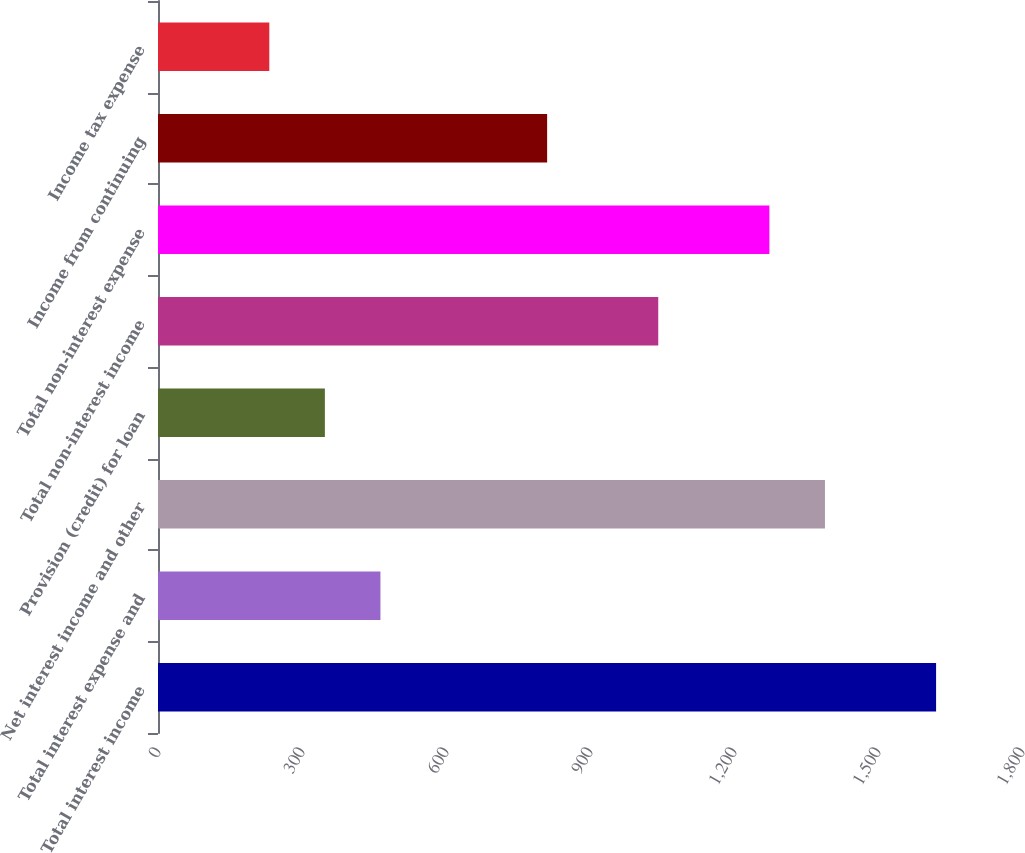Convert chart. <chart><loc_0><loc_0><loc_500><loc_500><bar_chart><fcel>Total interest income<fcel>Total interest expense and<fcel>Net interest income and other<fcel>Provision (credit) for loan<fcel>Total non-interest income<fcel>Total non-interest expense<fcel>Income from continuing<fcel>Income tax expense<nl><fcel>1621.01<fcel>463.41<fcel>1389.49<fcel>347.65<fcel>1042.21<fcel>1273.73<fcel>810.69<fcel>231.89<nl></chart> 